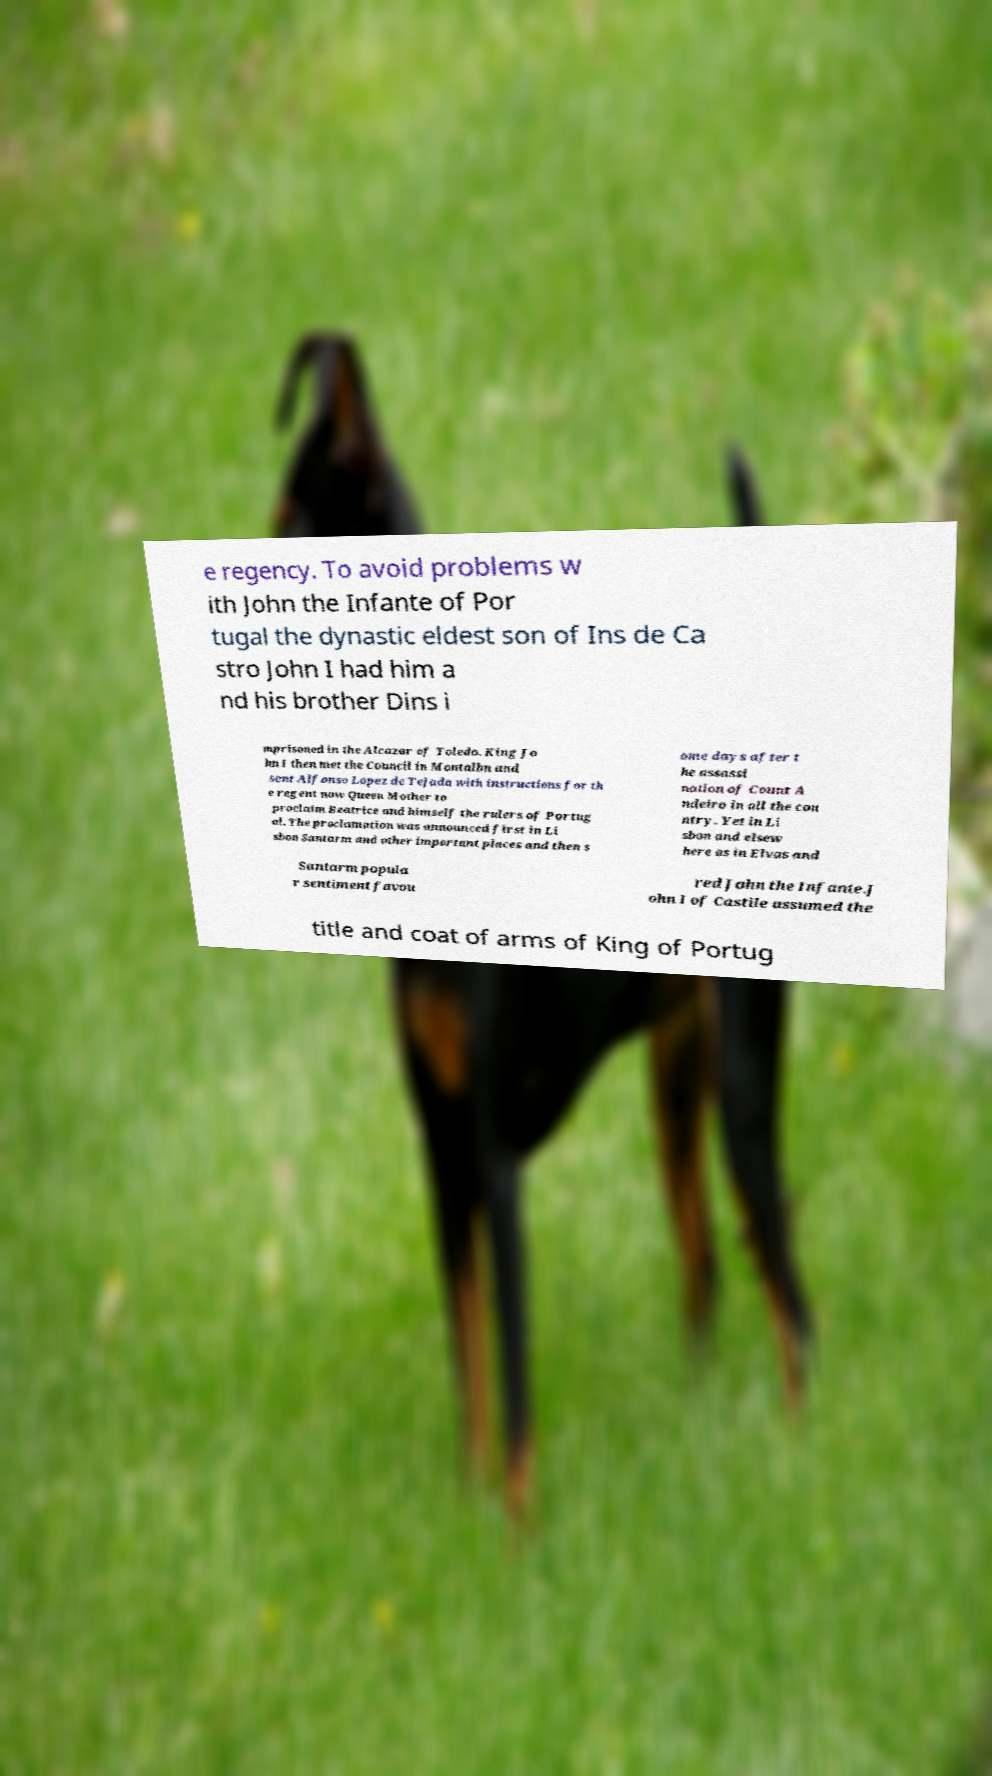Can you accurately transcribe the text from the provided image for me? e regency. To avoid problems w ith John the Infante of Por tugal the dynastic eldest son of Ins de Ca stro John I had him a nd his brother Dins i mprisoned in the Alcazar of Toledo. King Jo hn I then met the Council in Montalbn and sent Alfonso Lopez de Tejada with instructions for th e regent now Queen Mother to proclaim Beatrice and himself the rulers of Portug al. The proclamation was announced first in Li sbon Santarm and other important places and then s ome days after t he assassi nation of Count A ndeiro in all the cou ntry. Yet in Li sbon and elsew here as in Elvas and Santarm popula r sentiment favou red John the Infante.J ohn I of Castile assumed the title and coat of arms of King of Portug 